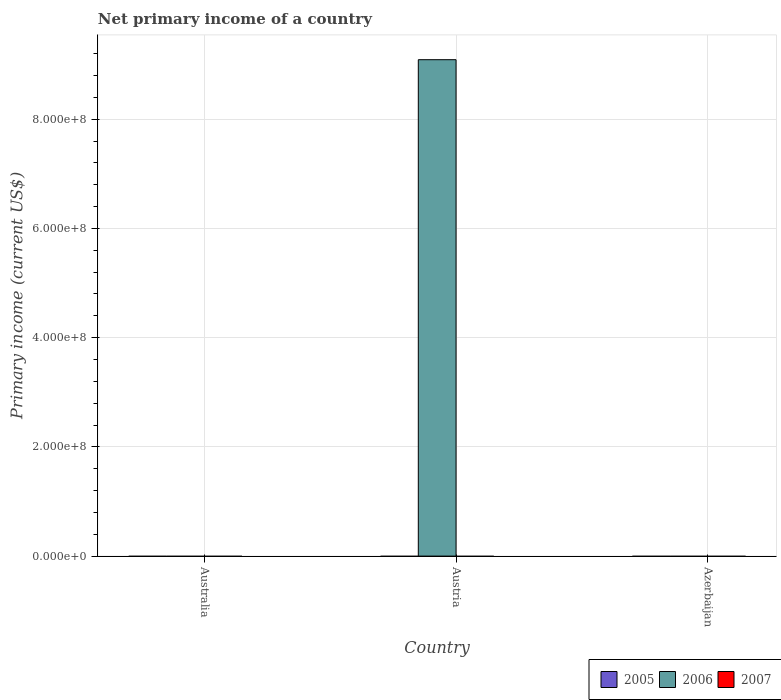How many different coloured bars are there?
Your answer should be compact. 1. How many bars are there on the 2nd tick from the left?
Give a very brief answer. 1. How many bars are there on the 3rd tick from the right?
Your answer should be very brief. 0. Across all countries, what is the maximum primary income in 2006?
Make the answer very short. 9.09e+08. What is the total primary income in 2006 in the graph?
Your response must be concise. 9.09e+08. What is the difference between the primary income in 2007 in Australia and the primary income in 2006 in Austria?
Your answer should be compact. -9.09e+08. In how many countries, is the primary income in 2007 greater than 440000000 US$?
Make the answer very short. 0. In how many countries, is the primary income in 2006 greater than the average primary income in 2006 taken over all countries?
Provide a short and direct response. 1. How many bars are there?
Provide a short and direct response. 1. Are all the bars in the graph horizontal?
Ensure brevity in your answer.  No. Are the values on the major ticks of Y-axis written in scientific E-notation?
Make the answer very short. Yes. How are the legend labels stacked?
Your answer should be very brief. Horizontal. What is the title of the graph?
Keep it short and to the point. Net primary income of a country. What is the label or title of the Y-axis?
Give a very brief answer. Primary income (current US$). What is the Primary income (current US$) of 2005 in Australia?
Make the answer very short. 0. What is the Primary income (current US$) in 2006 in Australia?
Provide a short and direct response. 0. What is the Primary income (current US$) in 2006 in Austria?
Give a very brief answer. 9.09e+08. Across all countries, what is the maximum Primary income (current US$) in 2006?
Ensure brevity in your answer.  9.09e+08. What is the total Primary income (current US$) of 2005 in the graph?
Give a very brief answer. 0. What is the total Primary income (current US$) in 2006 in the graph?
Your response must be concise. 9.09e+08. What is the total Primary income (current US$) in 2007 in the graph?
Give a very brief answer. 0. What is the average Primary income (current US$) in 2006 per country?
Offer a terse response. 3.03e+08. What is the average Primary income (current US$) of 2007 per country?
Keep it short and to the point. 0. What is the difference between the highest and the lowest Primary income (current US$) of 2006?
Offer a terse response. 9.09e+08. 